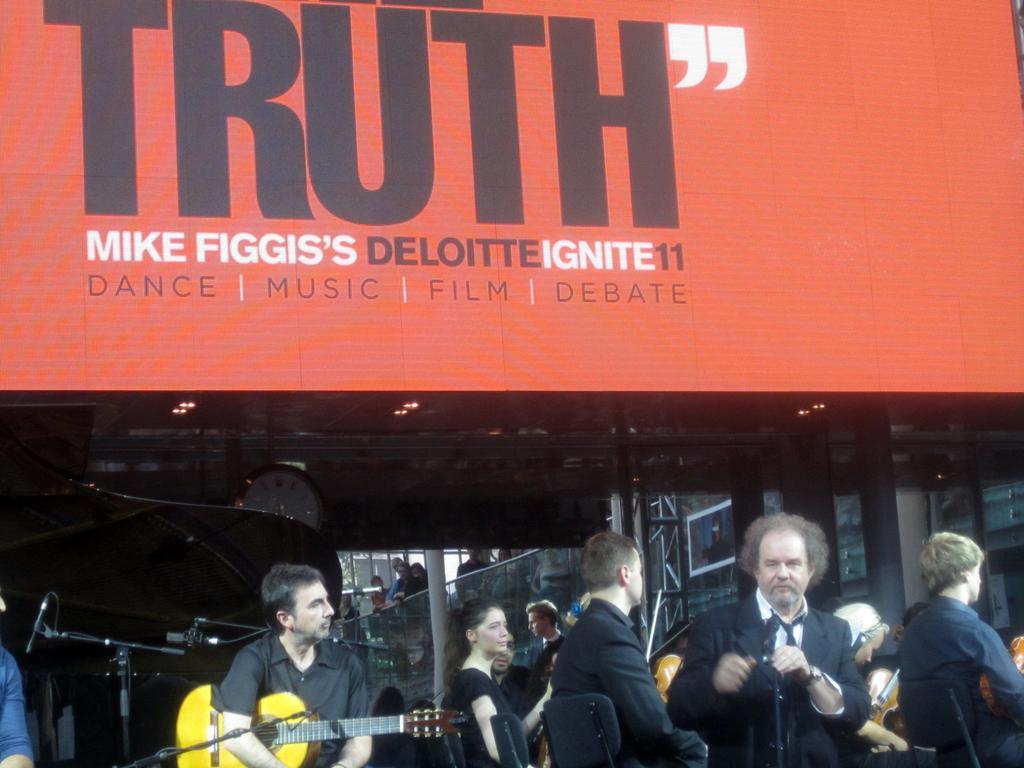Describe this image in one or two sentences. In this image we can see a group of people, some people are sitting on chairs holding musical instruments. In the foreground of the image we can see some microphones on stands, a piano and a clock. In the center of the image we can see a metal frame, a poster with a picture. At the top of the image we can see a screen with some text on it. 